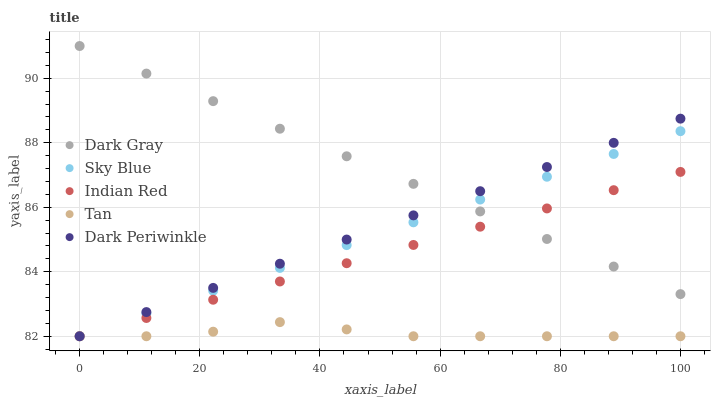Does Tan have the minimum area under the curve?
Answer yes or no. Yes. Does Dark Gray have the maximum area under the curve?
Answer yes or no. Yes. Does Sky Blue have the minimum area under the curve?
Answer yes or no. No. Does Sky Blue have the maximum area under the curve?
Answer yes or no. No. Is Dark Periwinkle the smoothest?
Answer yes or no. Yes. Is Tan the roughest?
Answer yes or no. Yes. Is Sky Blue the smoothest?
Answer yes or no. No. Is Sky Blue the roughest?
Answer yes or no. No. Does Sky Blue have the lowest value?
Answer yes or no. Yes. Does Dark Gray have the highest value?
Answer yes or no. Yes. Does Sky Blue have the highest value?
Answer yes or no. No. Is Tan less than Dark Gray?
Answer yes or no. Yes. Is Dark Gray greater than Tan?
Answer yes or no. Yes. Does Tan intersect Dark Periwinkle?
Answer yes or no. Yes. Is Tan less than Dark Periwinkle?
Answer yes or no. No. Is Tan greater than Dark Periwinkle?
Answer yes or no. No. Does Tan intersect Dark Gray?
Answer yes or no. No. 